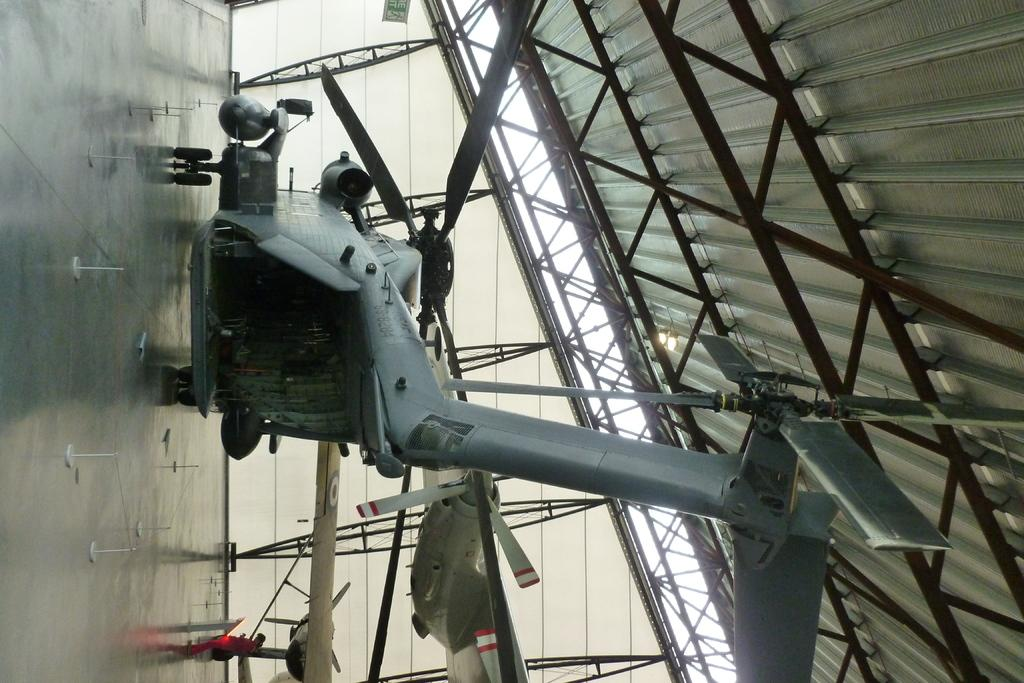What is the main subject of the image? The main subject of the image is a helicopter. Are there any other aircrafts in the image besides the helicopter? Yes, there are other aircrafts in the image. Can you describe the person in the image? There is a person standing in the image. What can be seen on the floor in the image? There are white-colored objects on the floor in the image. What type of island can be seen in the image? There is no island present in the image. What kind of flesh is visible on the helicopter in the image? There is no flesh visible on the helicopter in the image. 